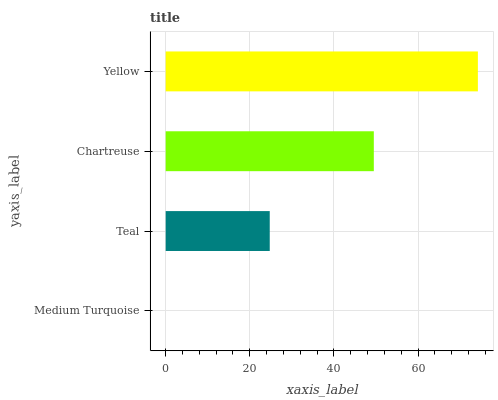Is Medium Turquoise the minimum?
Answer yes or no. Yes. Is Yellow the maximum?
Answer yes or no. Yes. Is Teal the minimum?
Answer yes or no. No. Is Teal the maximum?
Answer yes or no. No. Is Teal greater than Medium Turquoise?
Answer yes or no. Yes. Is Medium Turquoise less than Teal?
Answer yes or no. Yes. Is Medium Turquoise greater than Teal?
Answer yes or no. No. Is Teal less than Medium Turquoise?
Answer yes or no. No. Is Chartreuse the high median?
Answer yes or no. Yes. Is Teal the low median?
Answer yes or no. Yes. Is Yellow the high median?
Answer yes or no. No. Is Medium Turquoise the low median?
Answer yes or no. No. 